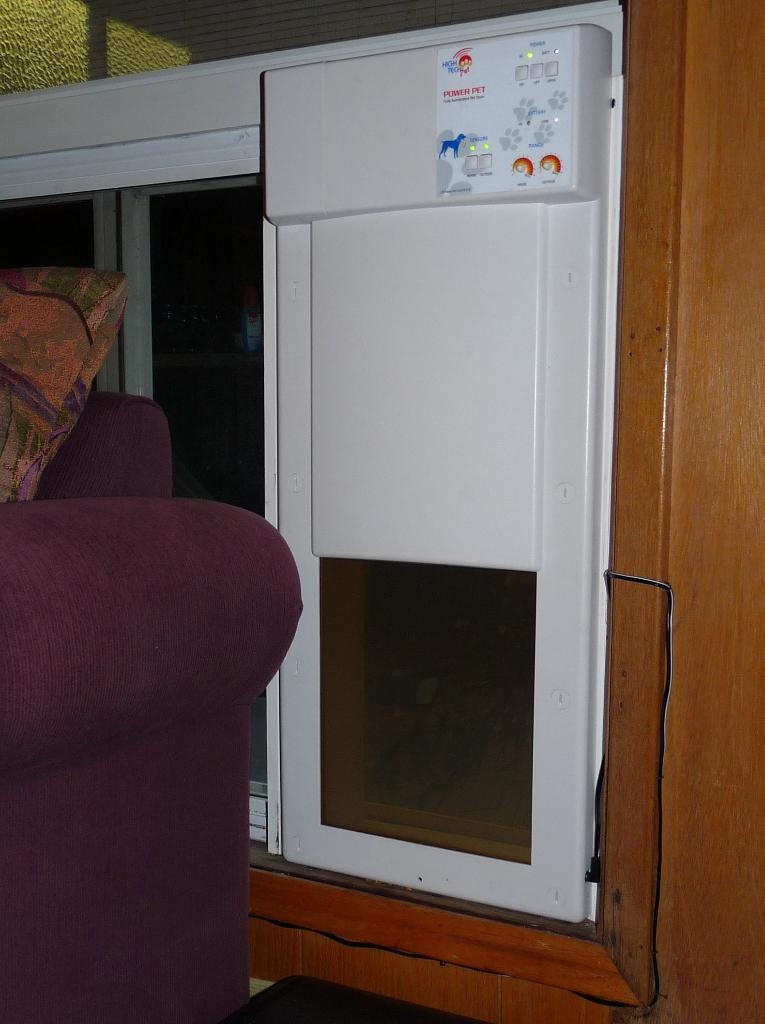<image>
Create a compact narrative representing the image presented. a white object with the word power pet on it 